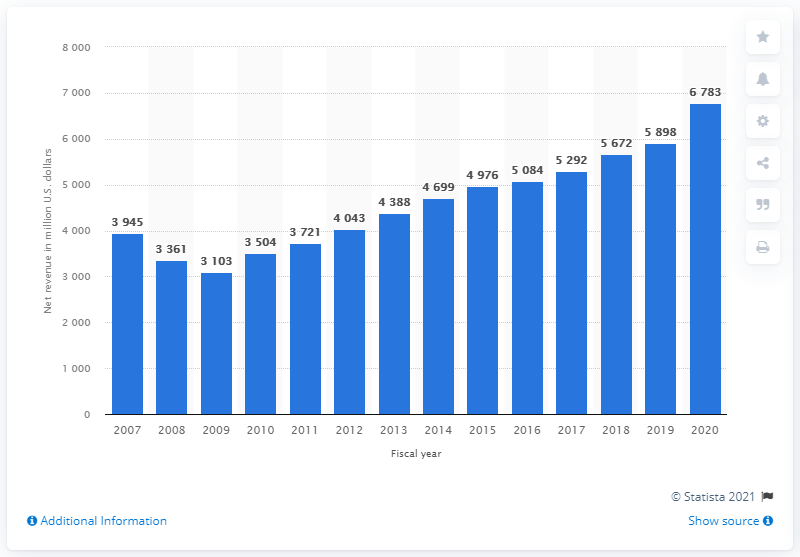Specify some key components in this picture. Williams-Sonoma's global net revenue in 2020 was $6,783 million. 